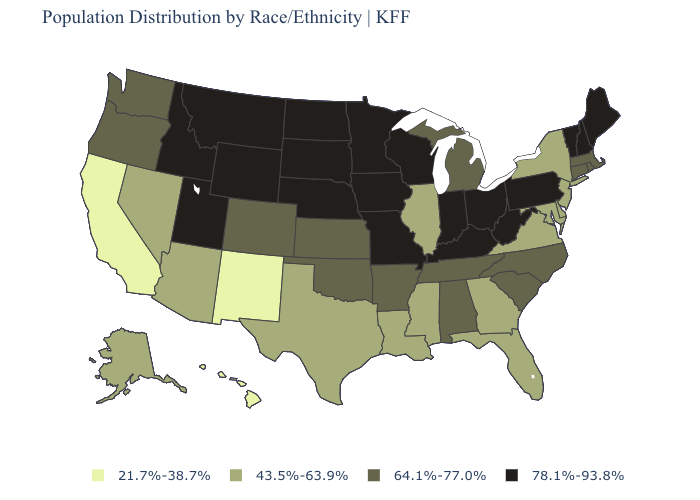What is the highest value in the USA?
Be succinct. 78.1%-93.8%. Which states have the lowest value in the USA?
Be succinct. California, Hawaii, New Mexico. Does Wyoming have the highest value in the West?
Be succinct. Yes. Which states have the lowest value in the Northeast?
Write a very short answer. New Jersey, New York. Among the states that border Indiana , does Illinois have the highest value?
Short answer required. No. What is the highest value in states that border California?
Quick response, please. 64.1%-77.0%. What is the value of Colorado?
Write a very short answer. 64.1%-77.0%. What is the value of Ohio?
Be succinct. 78.1%-93.8%. What is the lowest value in states that border Kansas?
Be succinct. 64.1%-77.0%. What is the value of Wyoming?
Give a very brief answer. 78.1%-93.8%. Does Illinois have a higher value than South Carolina?
Be succinct. No. Name the states that have a value in the range 64.1%-77.0%?
Short answer required. Alabama, Arkansas, Colorado, Connecticut, Kansas, Massachusetts, Michigan, North Carolina, Oklahoma, Oregon, Rhode Island, South Carolina, Tennessee, Washington. Is the legend a continuous bar?
Give a very brief answer. No. Name the states that have a value in the range 64.1%-77.0%?
Give a very brief answer. Alabama, Arkansas, Colorado, Connecticut, Kansas, Massachusetts, Michigan, North Carolina, Oklahoma, Oregon, Rhode Island, South Carolina, Tennessee, Washington. Which states have the highest value in the USA?
Keep it brief. Idaho, Indiana, Iowa, Kentucky, Maine, Minnesota, Missouri, Montana, Nebraska, New Hampshire, North Dakota, Ohio, Pennsylvania, South Dakota, Utah, Vermont, West Virginia, Wisconsin, Wyoming. 